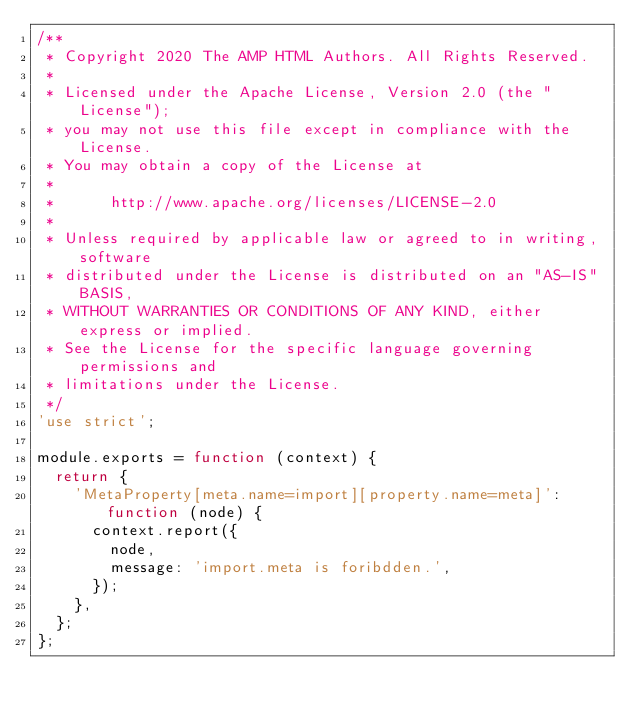Convert code to text. <code><loc_0><loc_0><loc_500><loc_500><_JavaScript_>/**
 * Copyright 2020 The AMP HTML Authors. All Rights Reserved.
 *
 * Licensed under the Apache License, Version 2.0 (the "License");
 * you may not use this file except in compliance with the License.
 * You may obtain a copy of the License at
 *
 *      http://www.apache.org/licenses/LICENSE-2.0
 *
 * Unless required by applicable law or agreed to in writing, software
 * distributed under the License is distributed on an "AS-IS" BASIS,
 * WITHOUT WARRANTIES OR CONDITIONS OF ANY KIND, either express or implied.
 * See the License for the specific language governing permissions and
 * limitations under the License.
 */
'use strict';

module.exports = function (context) {
  return {
    'MetaProperty[meta.name=import][property.name=meta]': function (node) {
      context.report({
        node,
        message: 'import.meta is foribdden.',
      });
    },
  };
};
</code> 